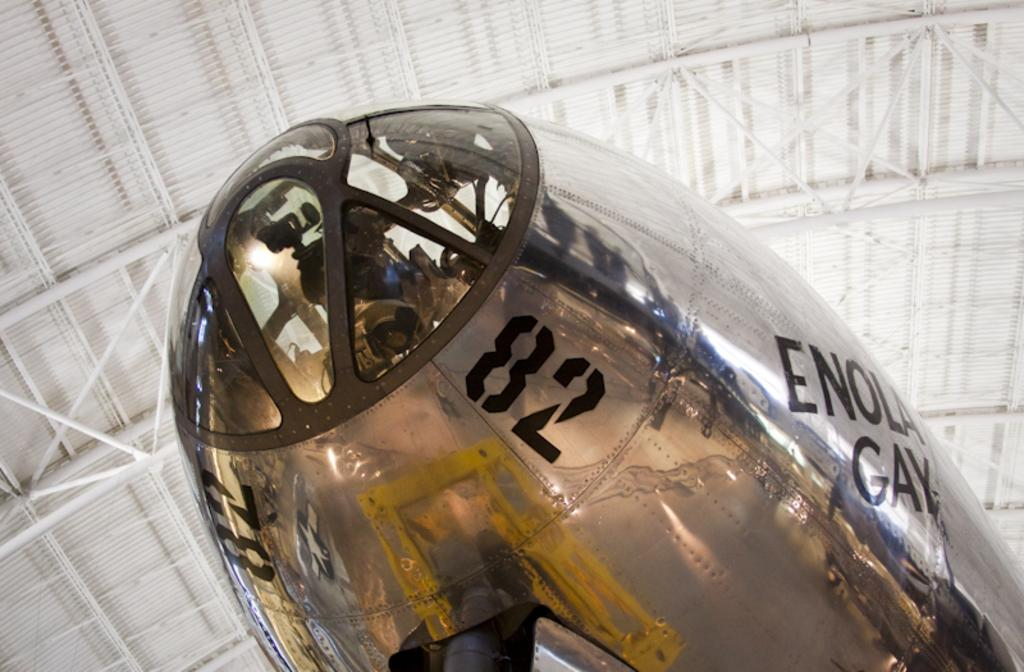What is the main subject of the image? The main subject of the image is an aircraft. Are there any words or letters on the aircraft? Yes, there is text written on the aircraft. What is located above the aircraft in the image? There is a roof above the aircraft. How many fowl can be seen on the roof above the aircraft? There are no fowl present on the roof above the aircraft in the image. What type of island is visible in the background of the image? There is no island visible in the image; it only features an aircraft with text and a roof above it. 